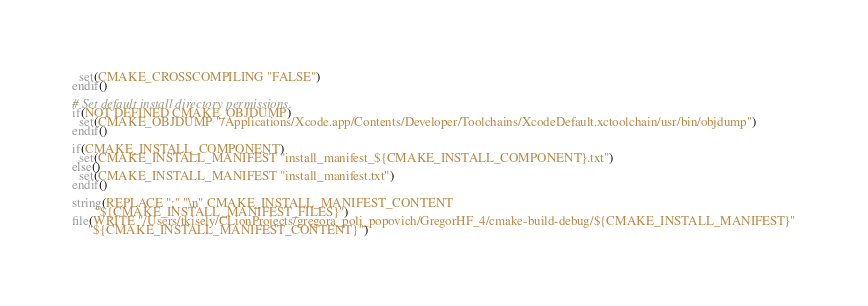Convert code to text. <code><loc_0><loc_0><loc_500><loc_500><_CMake_>  set(CMAKE_CROSSCOMPILING "FALSE")
endif()

# Set default install directory permissions.
if(NOT DEFINED CMAKE_OBJDUMP)
  set(CMAKE_OBJDUMP "/Applications/Xcode.app/Contents/Developer/Toolchains/XcodeDefault.xctoolchain/usr/bin/objdump")
endif()

if(CMAKE_INSTALL_COMPONENT)
  set(CMAKE_INSTALL_MANIFEST "install_manifest_${CMAKE_INSTALL_COMPONENT}.txt")
else()
  set(CMAKE_INSTALL_MANIFEST "install_manifest.txt")
endif()

string(REPLACE ";" "\n" CMAKE_INSTALL_MANIFEST_CONTENT
       "${CMAKE_INSTALL_MANIFEST_FILES}")
file(WRITE "/Users/tkisely/CLionProjects/gregora_poli_popovich/GregorHF_4/cmake-build-debug/${CMAKE_INSTALL_MANIFEST}"
     "${CMAKE_INSTALL_MANIFEST_CONTENT}")
</code> 